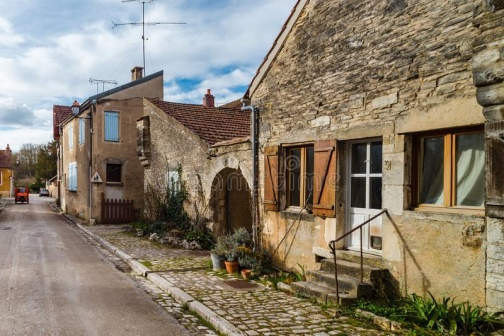Can you describe any specific features of the houses in this village? The houses in this village are made from stone, giving them a rustic and enduring look. The house on the far right has a small garden area with potted plants, enhancing its homely appeal. This house's windows are wooden with solid brown shutters. The middle house features a white door and green shutters on its window, which contrasts nicely with the stone. The house on the left stands out with a vivid blue door and is complemented by white shutters. Each house's orange roof adds a unified yet warm touch to the whole scene. 